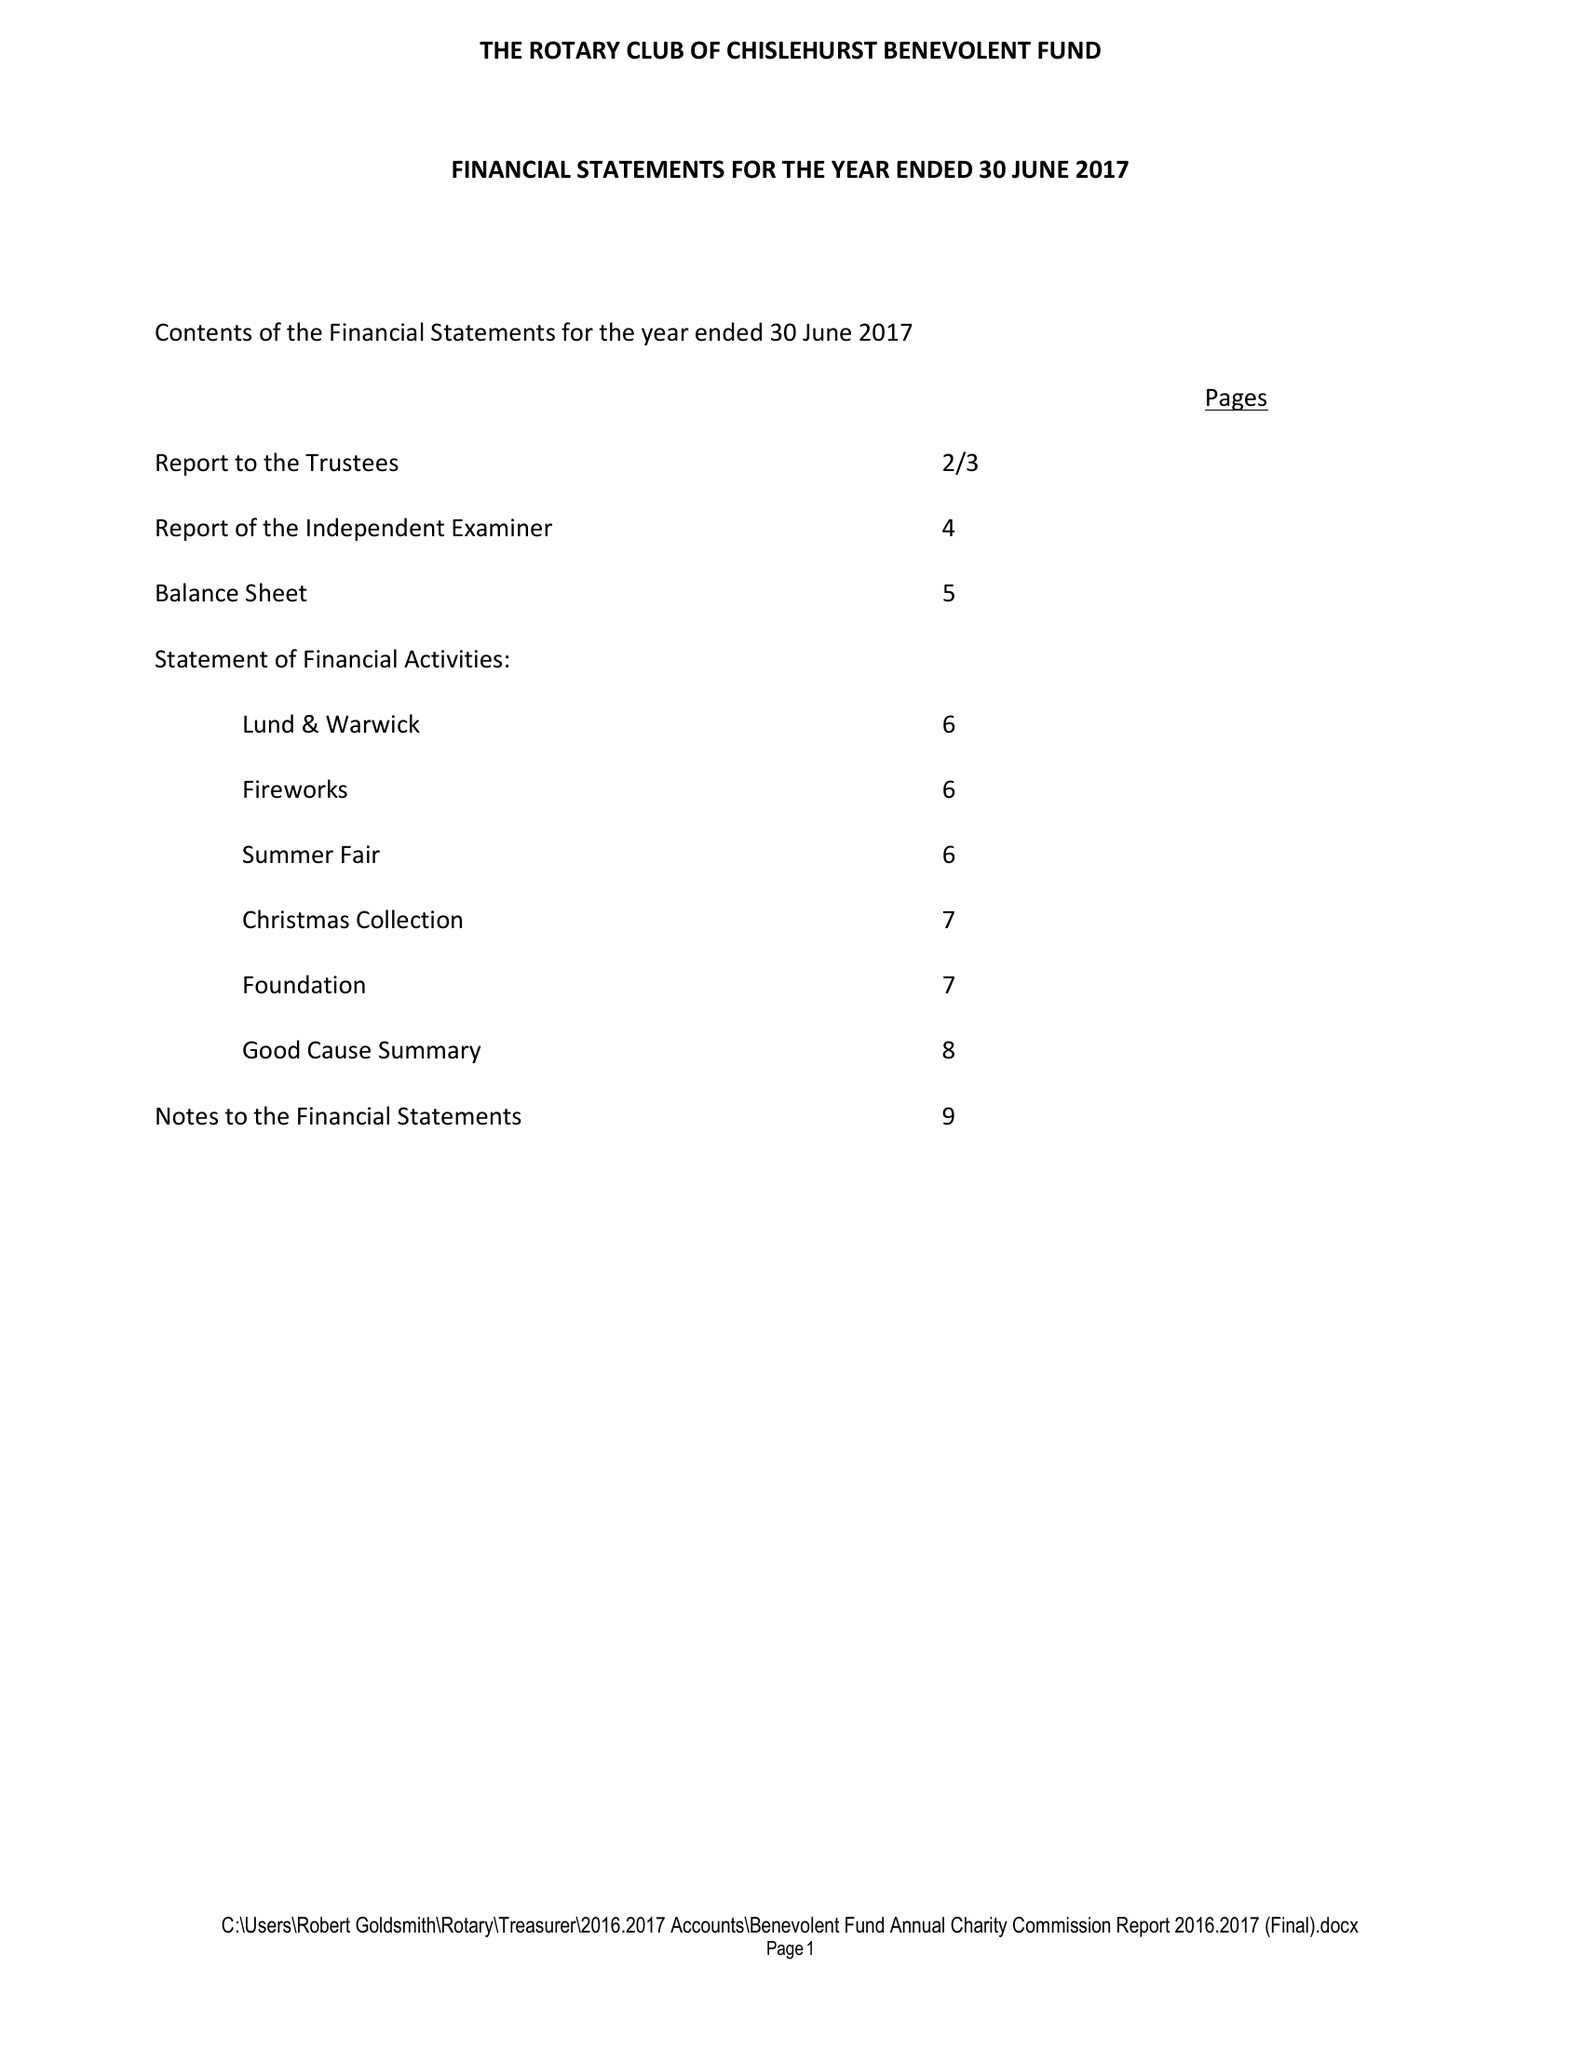What is the value for the charity_name?
Answer the question using a single word or phrase. The Rotary Club Of Chislehurst Benevolent Fund 